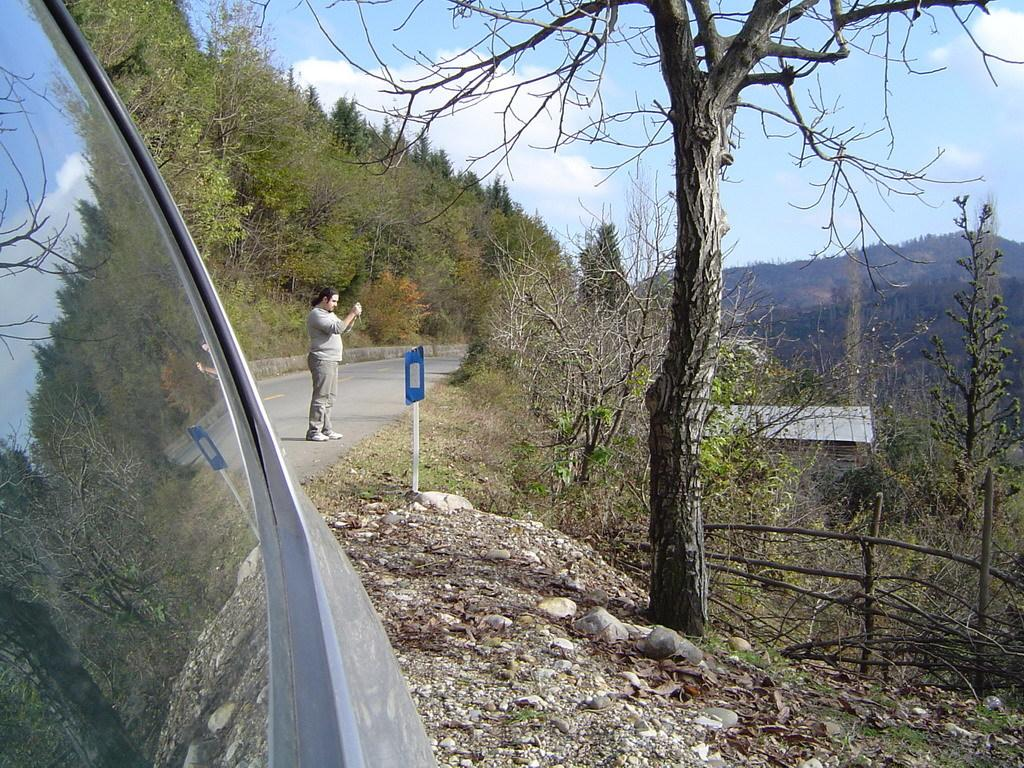What is the person in the image doing? The person is standing on the road. What can be seen in the background of the image? There are trees visible in the image. What color is the sky in the image? The sky is blue in the image. What type of basket is the person carrying, filled with tomatoes, in the image? There is no basket or tomatoes present in the image. What type of blade is the person using to cut the trees in the image? There is no blade or tree-cutting activity depicted in the image. 